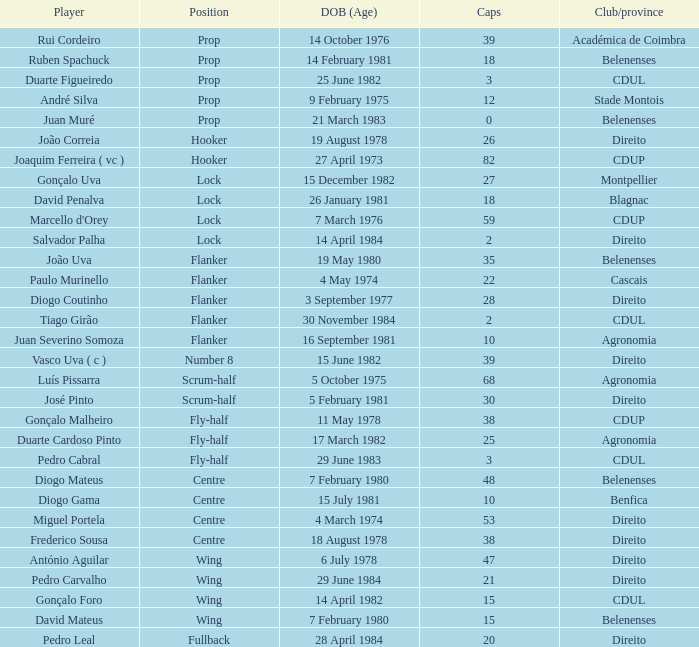How many caps were born on july 15, 1981 (age)? 1.0. Could you help me parse every detail presented in this table? {'header': ['Player', 'Position', 'DOB (Age)', 'Caps', 'Club/province'], 'rows': [['Rui Cordeiro', 'Prop', '14 October 1976', '39', 'Académica de Coimbra'], ['Ruben Spachuck', 'Prop', '14 February 1981', '18', 'Belenenses'], ['Duarte Figueiredo', 'Prop', '25 June 1982', '3', 'CDUL'], ['André Silva', 'Prop', '9 February 1975', '12', 'Stade Montois'], ['Juan Muré', 'Prop', '21 March 1983', '0', 'Belenenses'], ['João Correia', 'Hooker', '19 August 1978', '26', 'Direito'], ['Joaquim Ferreira ( vc )', 'Hooker', '27 April 1973', '82', 'CDUP'], ['Gonçalo Uva', 'Lock', '15 December 1982', '27', 'Montpellier'], ['David Penalva', 'Lock', '26 January 1981', '18', 'Blagnac'], ["Marcello d'Orey", 'Lock', '7 March 1976', '59', 'CDUP'], ['Salvador Palha', 'Lock', '14 April 1984', '2', 'Direito'], ['João Uva', 'Flanker', '19 May 1980', '35', 'Belenenses'], ['Paulo Murinello', 'Flanker', '4 May 1974', '22', 'Cascais'], ['Diogo Coutinho', 'Flanker', '3 September 1977', '28', 'Direito'], ['Tiago Girão', 'Flanker', '30 November 1984', '2', 'CDUL'], ['Juan Severino Somoza', 'Flanker', '16 September 1981', '10', 'Agronomia'], ['Vasco Uva ( c )', 'Number 8', '15 June 1982', '39', 'Direito'], ['Luís Pissarra', 'Scrum-half', '5 October 1975', '68', 'Agronomia'], ['José Pinto', 'Scrum-half', '5 February 1981', '30', 'Direito'], ['Gonçalo Malheiro', 'Fly-half', '11 May 1978', '38', 'CDUP'], ['Duarte Cardoso Pinto', 'Fly-half', '17 March 1982', '25', 'Agronomia'], ['Pedro Cabral', 'Fly-half', '29 June 1983', '3', 'CDUL'], ['Diogo Mateus', 'Centre', '7 February 1980', '48', 'Belenenses'], ['Diogo Gama', 'Centre', '15 July 1981', '10', 'Benfica'], ['Miguel Portela', 'Centre', '4 March 1974', '53', 'Direito'], ['Frederico Sousa', 'Centre', '18 August 1978', '38', 'Direito'], ['António Aguilar', 'Wing', '6 July 1978', '47', 'Direito'], ['Pedro Carvalho', 'Wing', '29 June 1984', '21', 'Direito'], ['Gonçalo Foro', 'Wing', '14 April 1982', '15', 'CDUL'], ['David Mateus', 'Wing', '7 February 1980', '15', 'Belenenses'], ['Pedro Leal', 'Fullback', '28 April 1984', '20', 'Direito']]} 